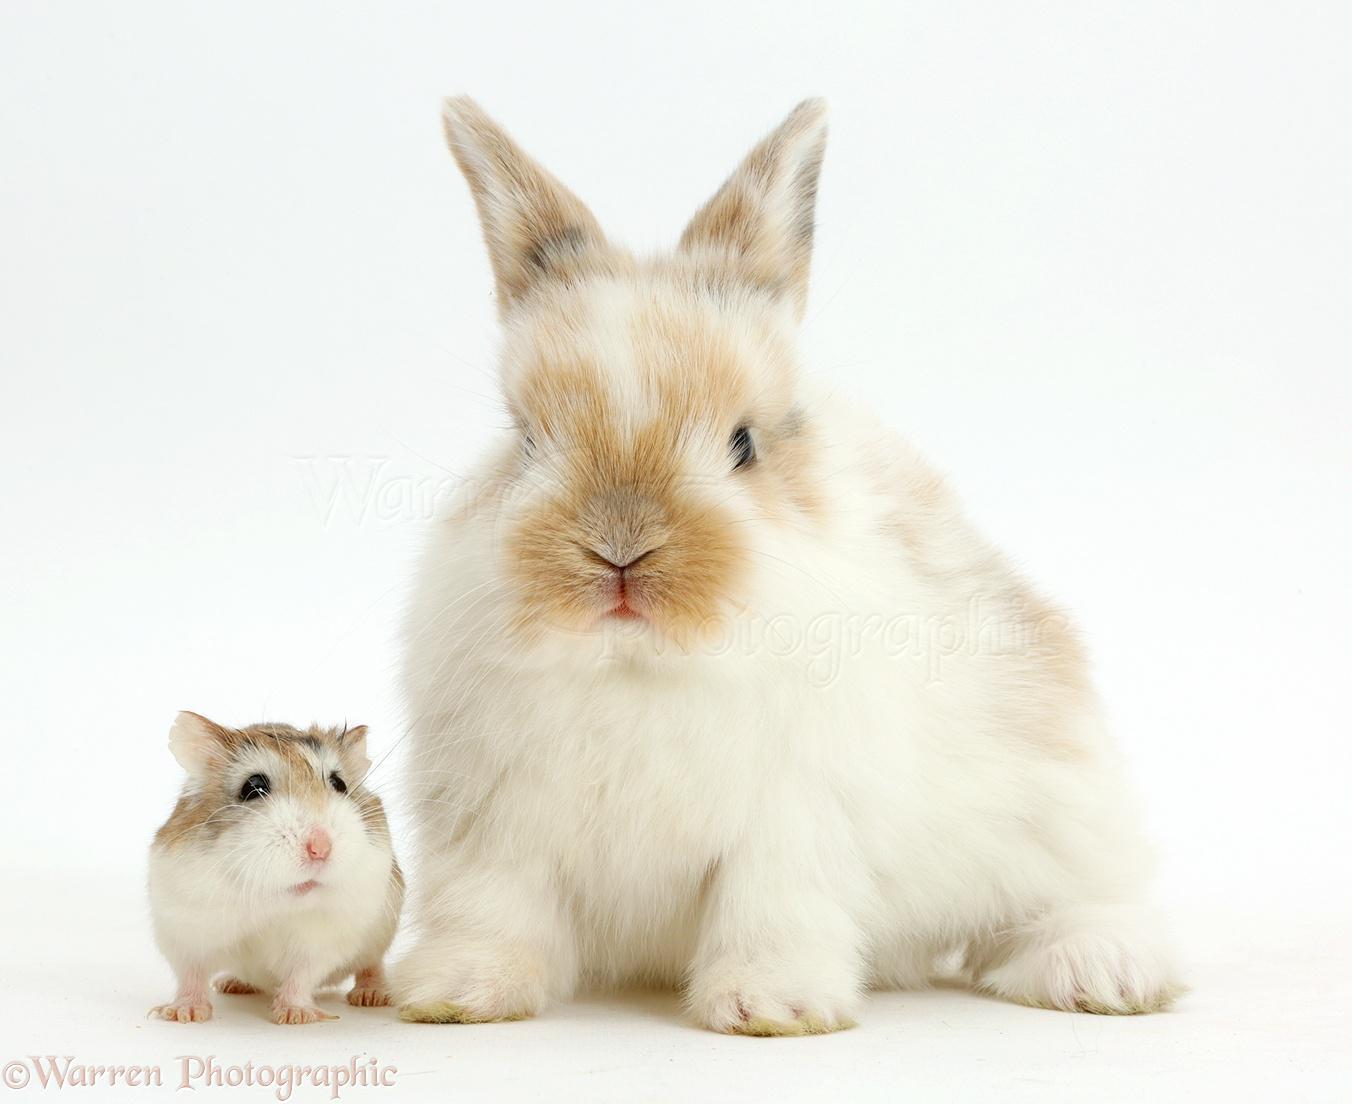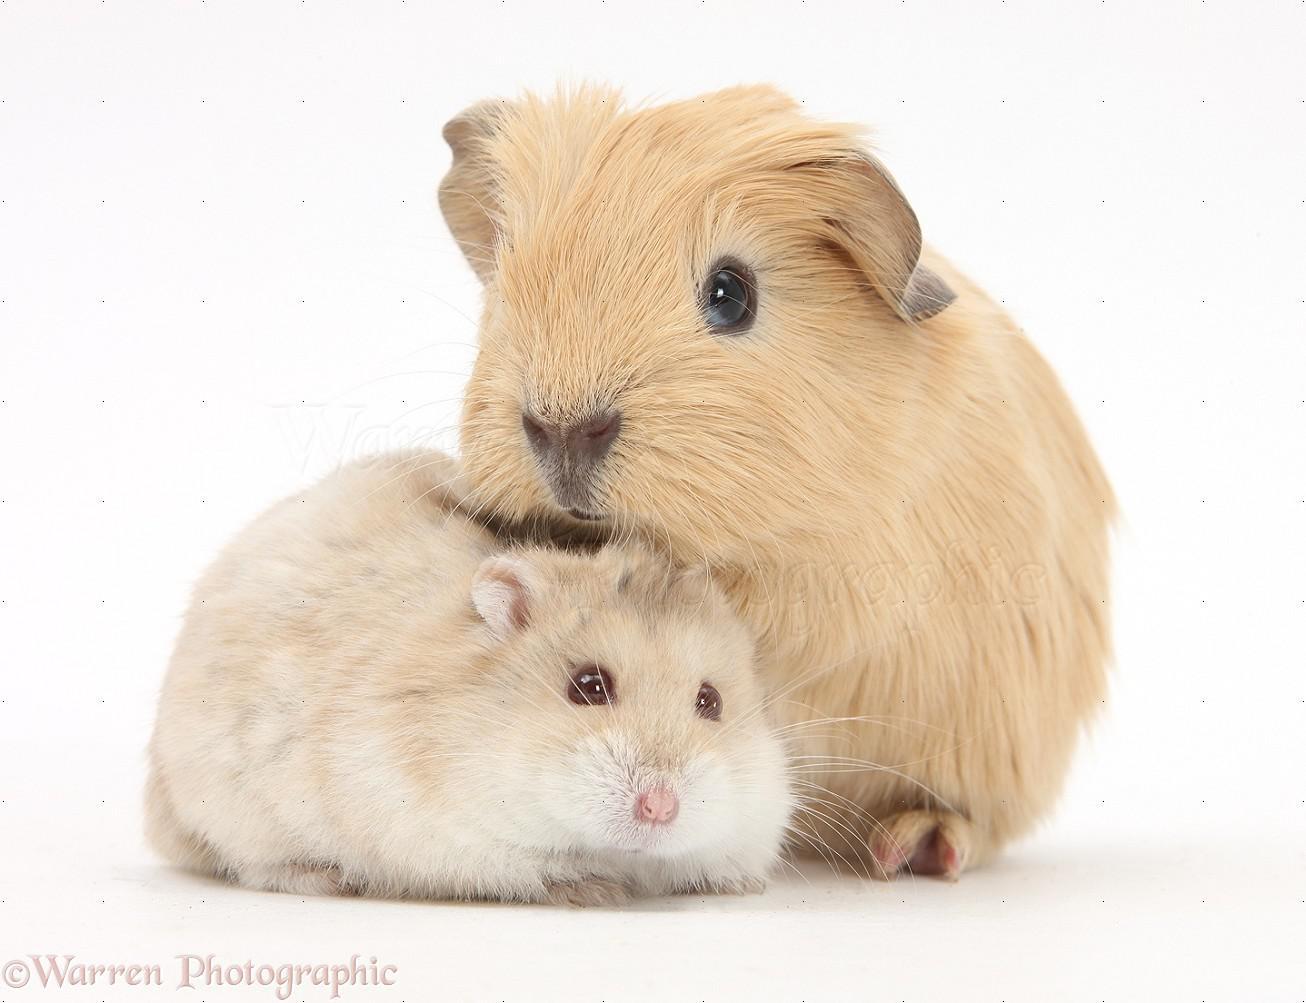The first image is the image on the left, the second image is the image on the right. For the images displayed, is the sentence "At least one image shows a small pet rodent posed with a larger pet animal on a white background." factually correct? Answer yes or no. Yes. The first image is the image on the left, the second image is the image on the right. Examine the images to the left and right. Is the description "The right image contains exactly two rodents." accurate? Answer yes or no. Yes. 